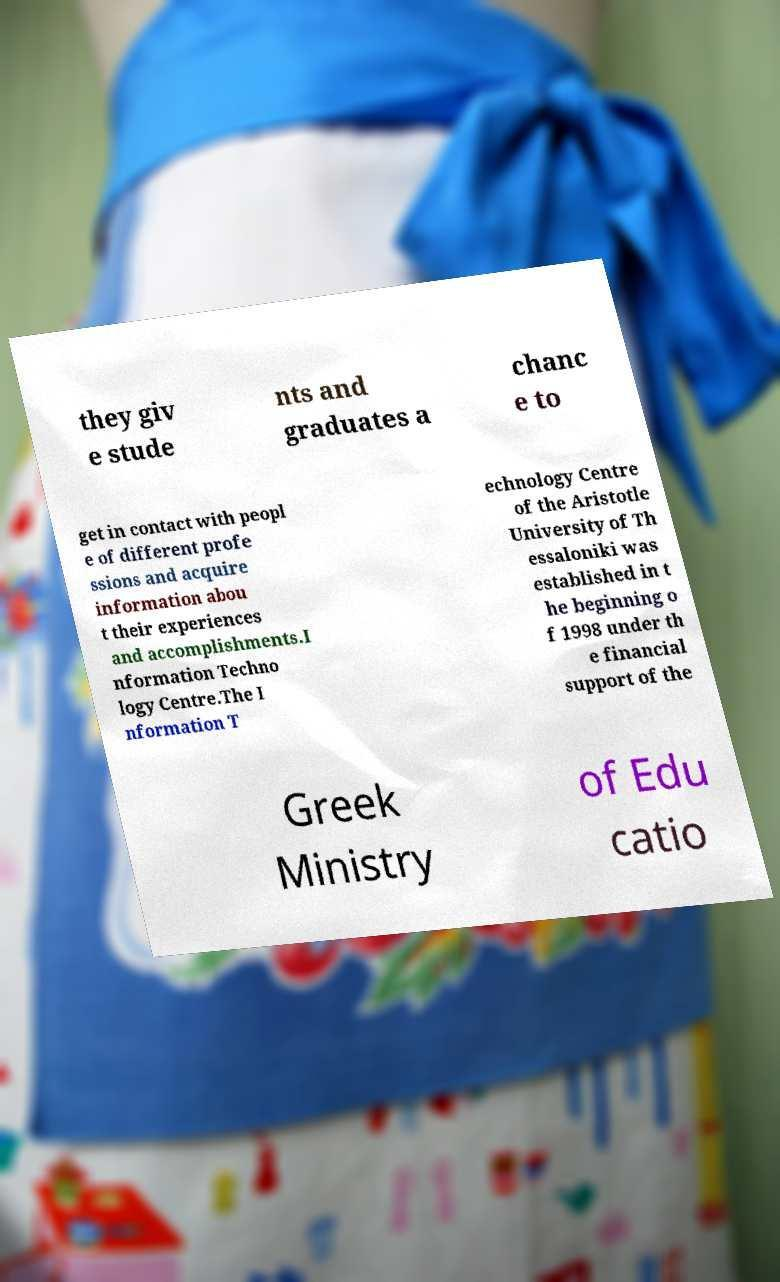Can you read and provide the text displayed in the image?This photo seems to have some interesting text. Can you extract and type it out for me? they giv e stude nts and graduates a chanc e to get in contact with peopl e of different profe ssions and acquire information abou t their experiences and accomplishments.I nformation Techno logy Centre.The I nformation T echnology Centre of the Aristotle University of Th essaloniki was established in t he beginning o f 1998 under th e financial support of the Greek Ministry of Edu catio 